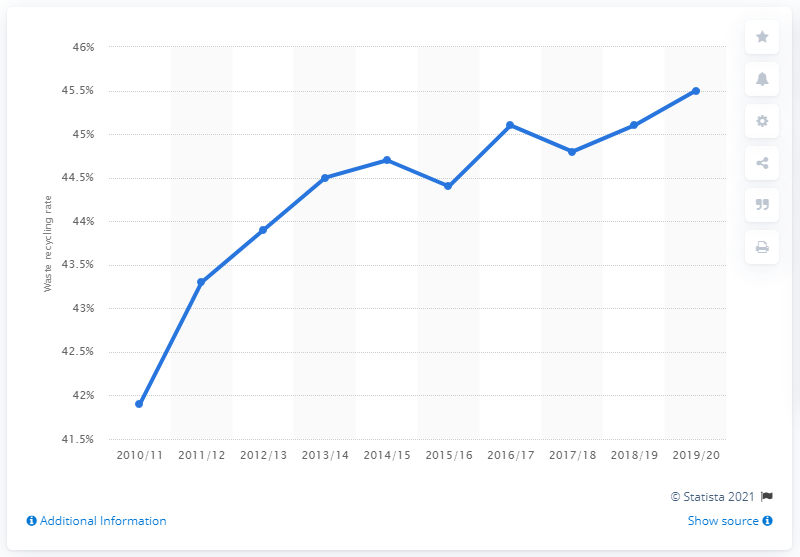Indicate a few pertinent items in this graphic. In 2019, the recycling rate for waste generated by households in England was 45.5%. 